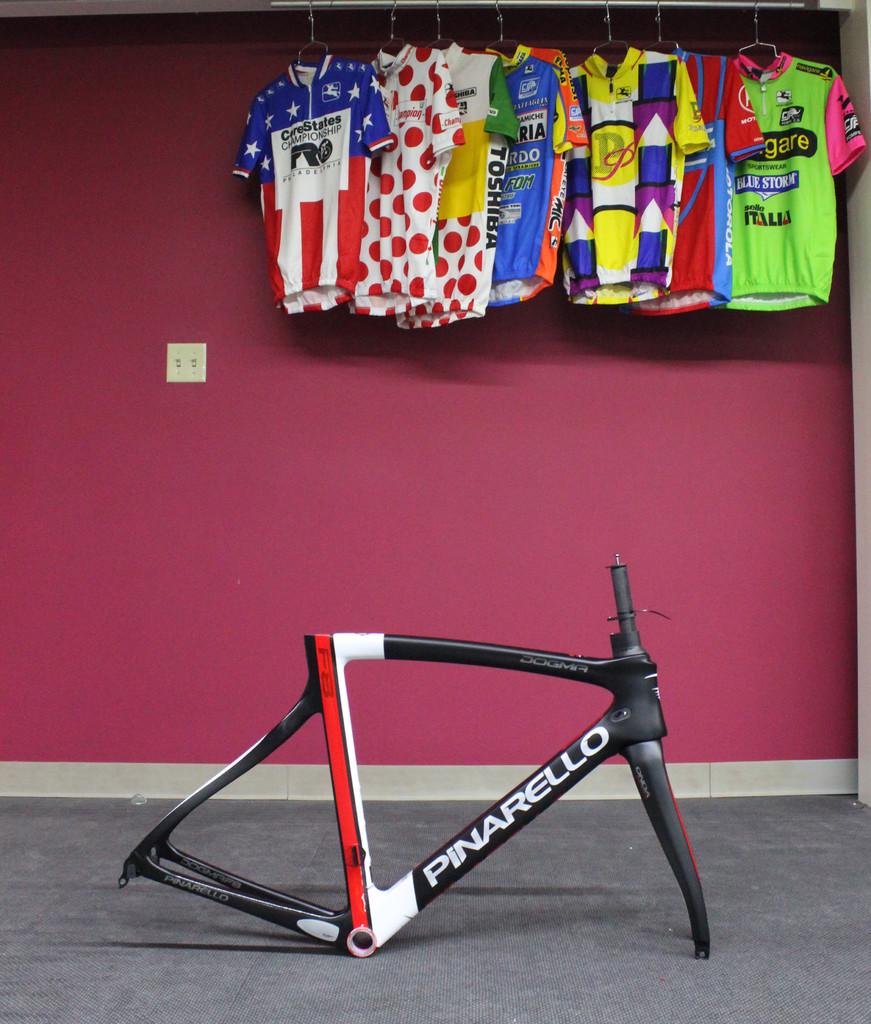What brand is the frame?
Give a very brief answer. Pinarello. What electronics brand is featured on the third shirt from the left?
Make the answer very short. Toshiba. 